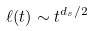Convert formula to latex. <formula><loc_0><loc_0><loc_500><loc_500>\ell ( t ) \sim t ^ { d _ { s } / 2 }</formula> 